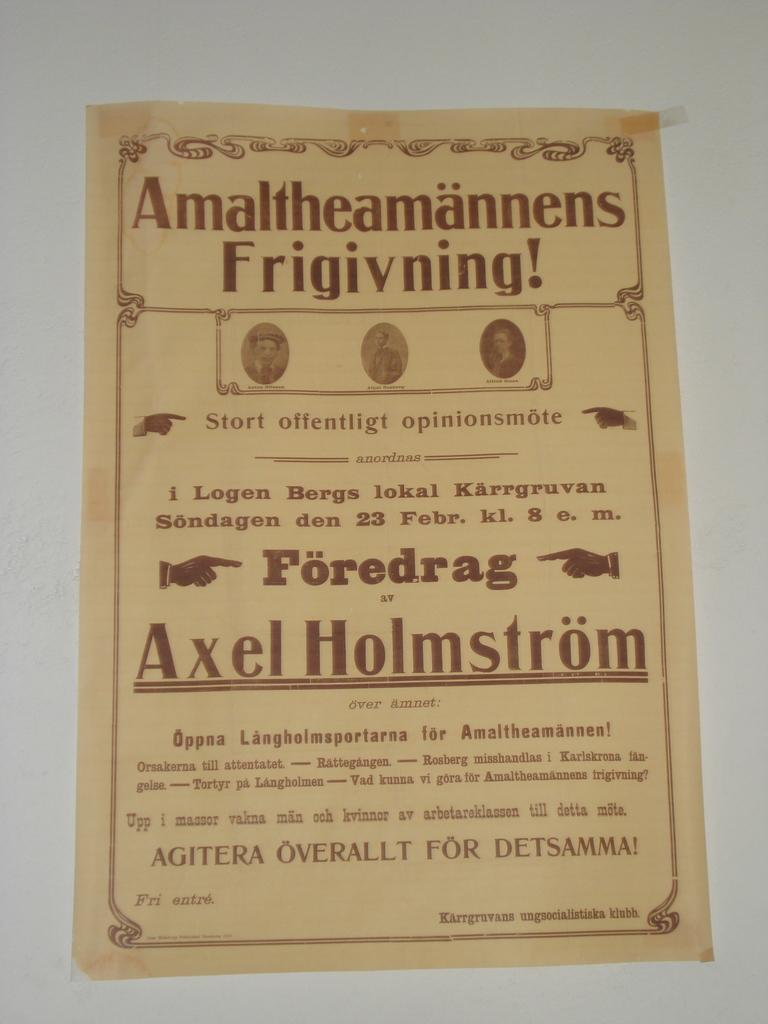Provide a one-sentence caption for the provided image. Some type of advertisement in another language that is featuring Axel Holmstrom. 